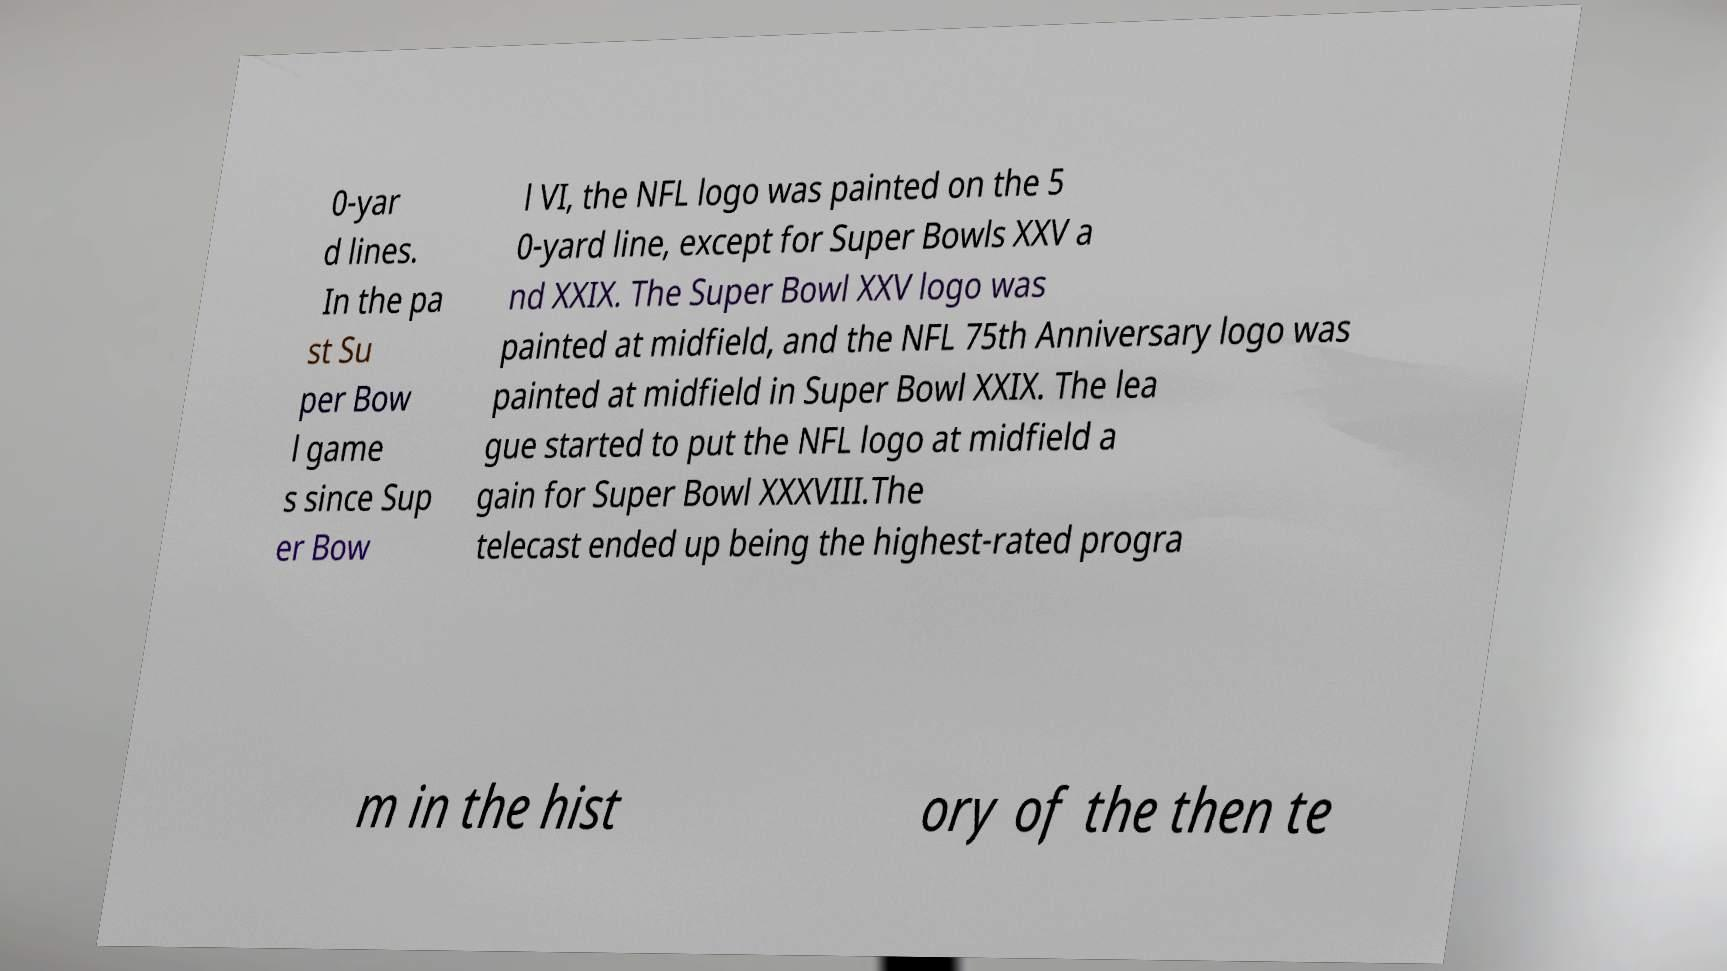Please identify and transcribe the text found in this image. 0-yar d lines. In the pa st Su per Bow l game s since Sup er Bow l VI, the NFL logo was painted on the 5 0-yard line, except for Super Bowls XXV a nd XXIX. The Super Bowl XXV logo was painted at midfield, and the NFL 75th Anniversary logo was painted at midfield in Super Bowl XXIX. The lea gue started to put the NFL logo at midfield a gain for Super Bowl XXXVIII.The telecast ended up being the highest-rated progra m in the hist ory of the then te 